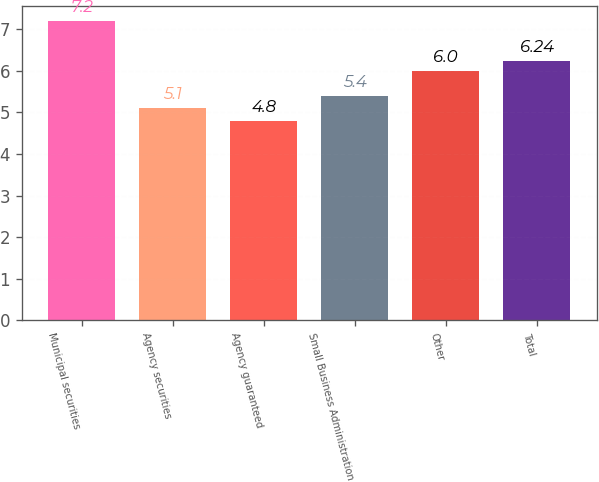<chart> <loc_0><loc_0><loc_500><loc_500><bar_chart><fcel>Municipal securities<fcel>Agency securities<fcel>Agency guaranteed<fcel>Small Business Administration<fcel>Other<fcel>Total<nl><fcel>7.2<fcel>5.1<fcel>4.8<fcel>5.4<fcel>6<fcel>6.24<nl></chart> 